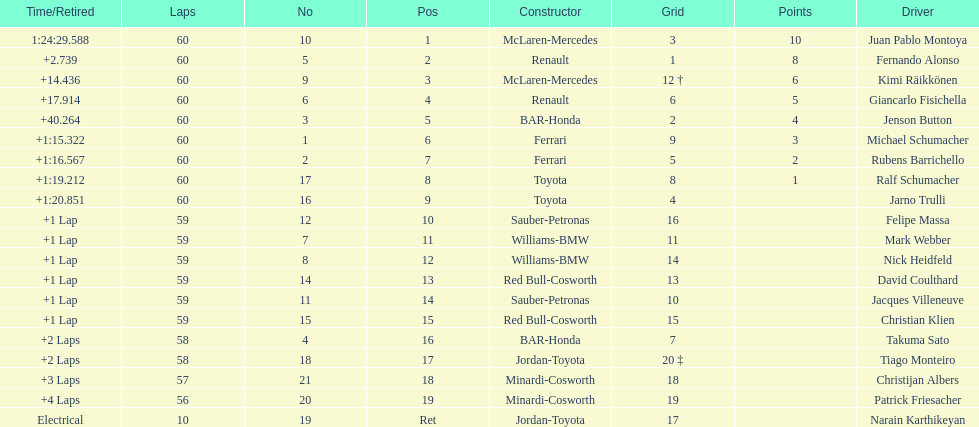Is there a points difference between the 9th position and 19th position on the list? No. 